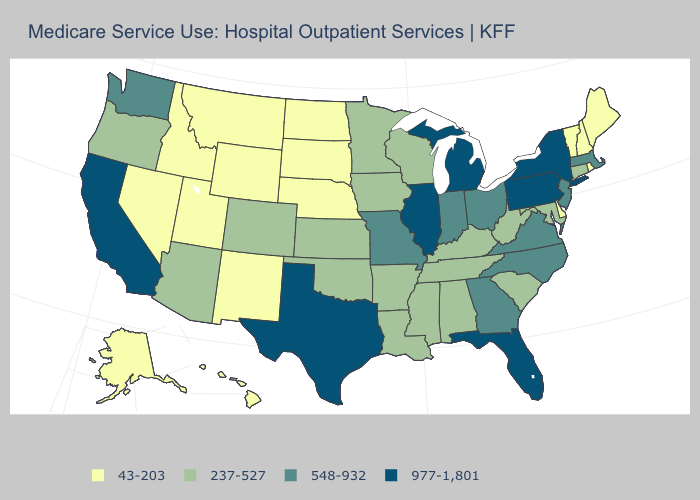What is the value of Texas?
Keep it brief. 977-1,801. Does the map have missing data?
Concise answer only. No. Does the map have missing data?
Concise answer only. No. Name the states that have a value in the range 43-203?
Be succinct. Alaska, Delaware, Hawaii, Idaho, Maine, Montana, Nebraska, Nevada, New Hampshire, New Mexico, North Dakota, Rhode Island, South Dakota, Utah, Vermont, Wyoming. Does Utah have the lowest value in the USA?
Give a very brief answer. Yes. Name the states that have a value in the range 977-1,801?
Quick response, please. California, Florida, Illinois, Michigan, New York, Pennsylvania, Texas. Does Mississippi have the lowest value in the South?
Be succinct. No. Name the states that have a value in the range 43-203?
Write a very short answer. Alaska, Delaware, Hawaii, Idaho, Maine, Montana, Nebraska, Nevada, New Hampshire, New Mexico, North Dakota, Rhode Island, South Dakota, Utah, Vermont, Wyoming. Does Alaska have the highest value in the West?
Quick response, please. No. Does the first symbol in the legend represent the smallest category?
Give a very brief answer. Yes. What is the lowest value in the Northeast?
Short answer required. 43-203. What is the highest value in states that border Arkansas?
Concise answer only. 977-1,801. What is the lowest value in the USA?
Give a very brief answer. 43-203. What is the value of Nebraska?
Answer briefly. 43-203. Name the states that have a value in the range 43-203?
Quick response, please. Alaska, Delaware, Hawaii, Idaho, Maine, Montana, Nebraska, Nevada, New Hampshire, New Mexico, North Dakota, Rhode Island, South Dakota, Utah, Vermont, Wyoming. 